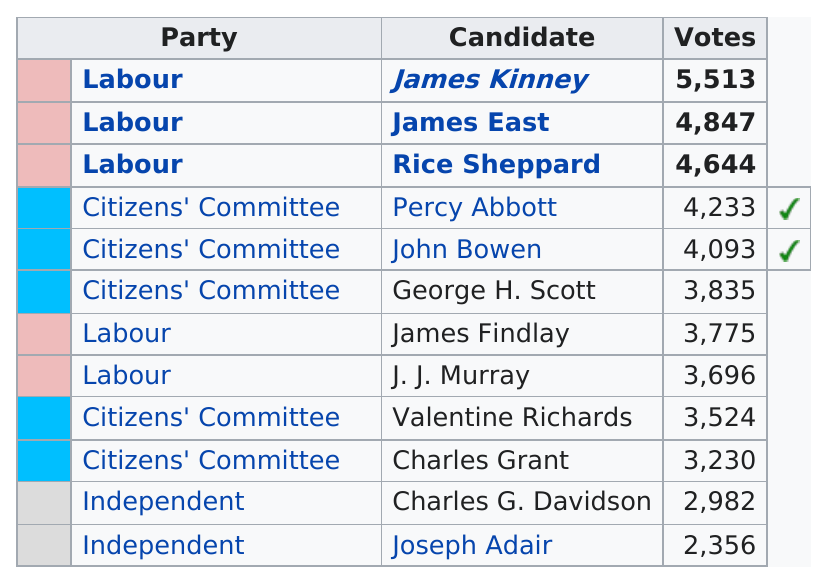Highlight a few significant elements in this photo. The candidate who received the most votes was James Kinney. The party that received the most votes after Labour was the Citizens' Committee. The party with fewer than three candidates but more than one was the Independent party. As of my knowledge cutoff date of September 2021, J.J. Murray has 3,696 votes. There were two independent candidates on the ballot for alderman in 1919. 